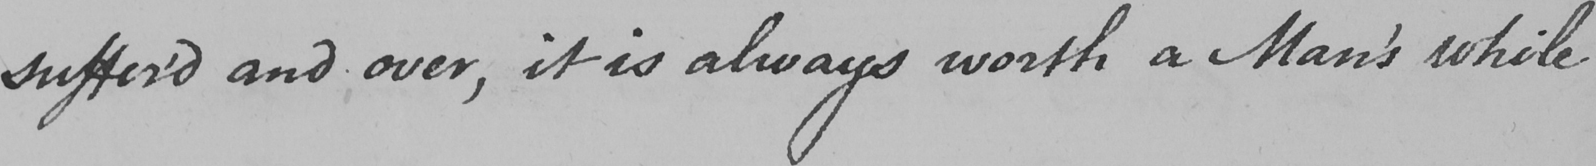What does this handwritten line say? suffer ' dand over , it is always worth a Man ' s while 